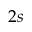Convert formula to latex. <formula><loc_0><loc_0><loc_500><loc_500>2 s</formula> 